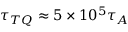Convert formula to latex. <formula><loc_0><loc_0><loc_500><loc_500>\tau _ { T Q } \approx 5 \times 1 0 ^ { 5 } \tau _ { A }</formula> 